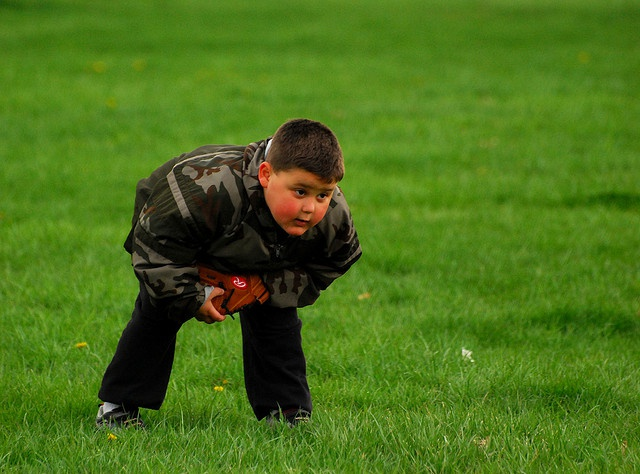Describe the objects in this image and their specific colors. I can see people in darkgreen, black, green, and maroon tones and baseball glove in darkgreen, maroon, black, and brown tones in this image. 